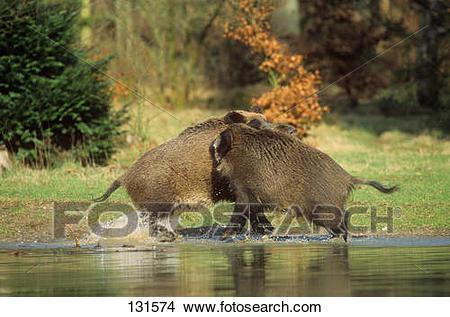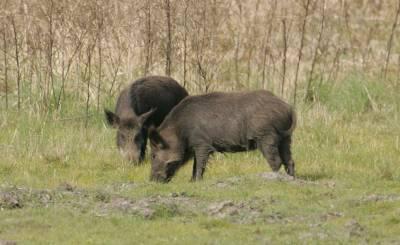The first image is the image on the left, the second image is the image on the right. Examine the images to the left and right. Is the description "Three adult wild pigs stand in green grass with at least one baby pig whose hair has distinctive stripes." accurate? Answer yes or no. No. The first image is the image on the left, the second image is the image on the right. For the images shown, is this caption "The right image contains exactly one boar." true? Answer yes or no. No. 